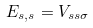<formula> <loc_0><loc_0><loc_500><loc_500>E _ { s , s } = V _ { s s \sigma }</formula> 